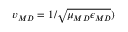<formula> <loc_0><loc_0><loc_500><loc_500>v _ { \/ { M D } } = 1 / \sqrt { \mu _ { \/ { M D } } \epsilon _ { \/ { M D } } } )</formula> 